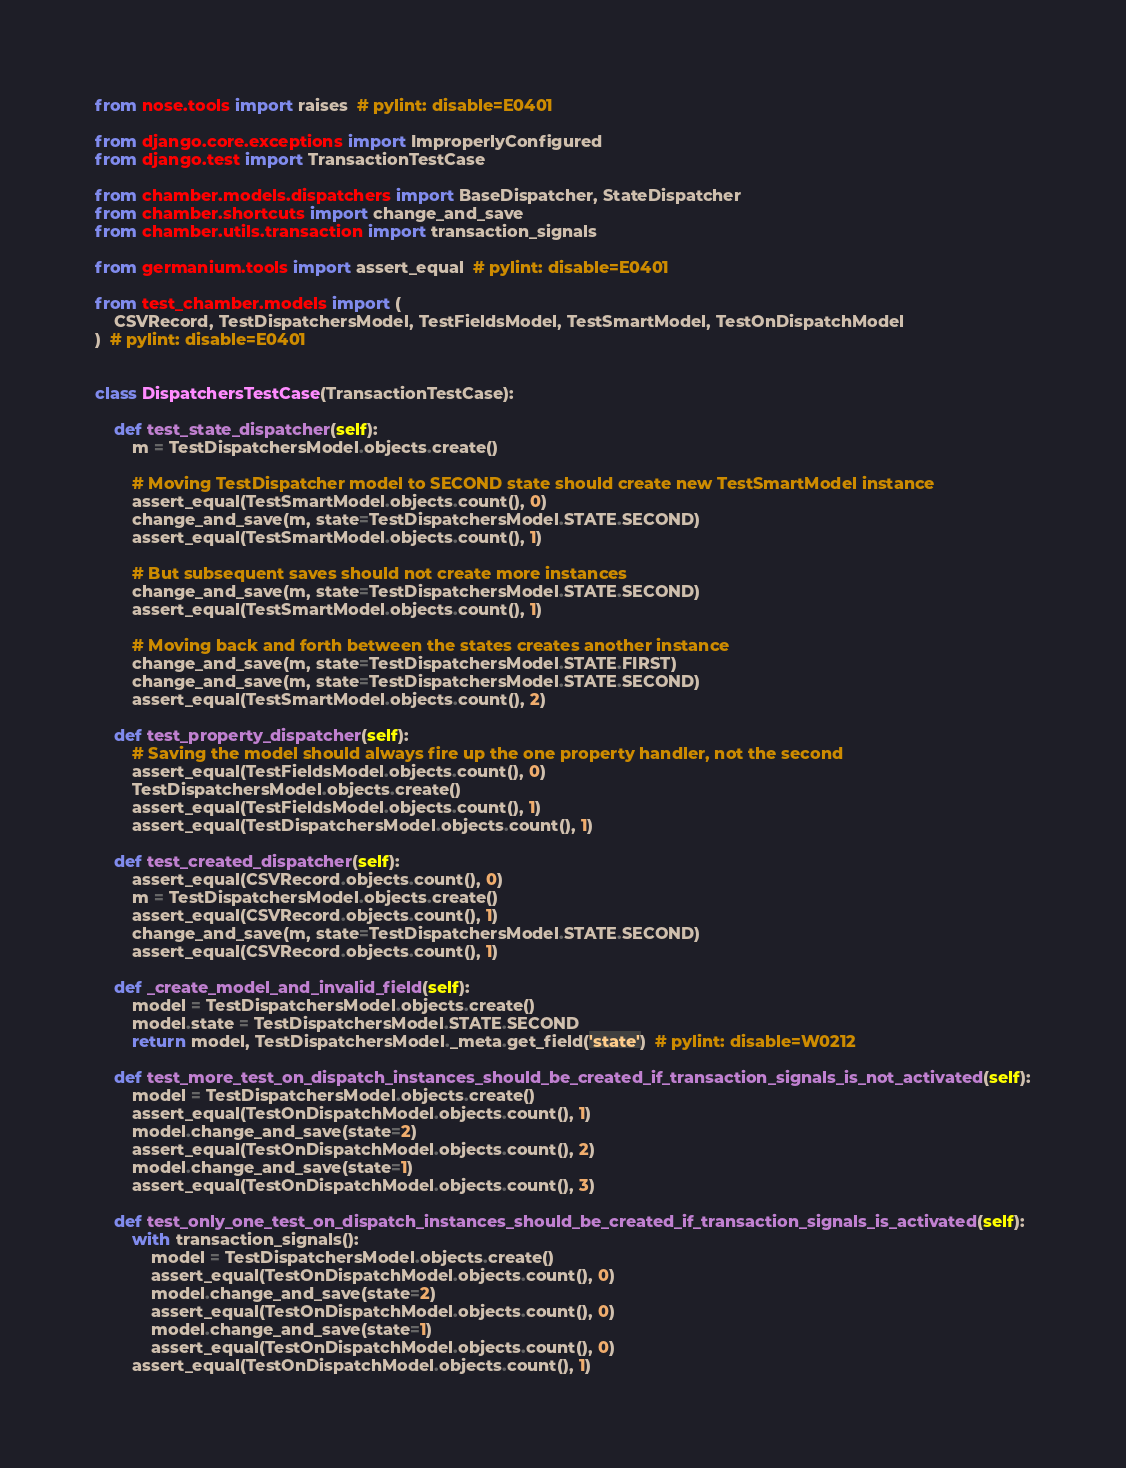Convert code to text. <code><loc_0><loc_0><loc_500><loc_500><_Python_>from nose.tools import raises  # pylint: disable=E0401

from django.core.exceptions import ImproperlyConfigured
from django.test import TransactionTestCase

from chamber.models.dispatchers import BaseDispatcher, StateDispatcher
from chamber.shortcuts import change_and_save
from chamber.utils.transaction import transaction_signals

from germanium.tools import assert_equal  # pylint: disable=E0401

from test_chamber.models import (
    CSVRecord, TestDispatchersModel, TestFieldsModel, TestSmartModel, TestOnDispatchModel
)  # pylint: disable=E0401


class DispatchersTestCase(TransactionTestCase):

    def test_state_dispatcher(self):
        m = TestDispatchersModel.objects.create()

        # Moving TestDispatcher model to SECOND state should create new TestSmartModel instance
        assert_equal(TestSmartModel.objects.count(), 0)
        change_and_save(m, state=TestDispatchersModel.STATE.SECOND)
        assert_equal(TestSmartModel.objects.count(), 1)

        # But subsequent saves should not create more instances
        change_and_save(m, state=TestDispatchersModel.STATE.SECOND)
        assert_equal(TestSmartModel.objects.count(), 1)

        # Moving back and forth between the states creates another instance
        change_and_save(m, state=TestDispatchersModel.STATE.FIRST)
        change_and_save(m, state=TestDispatchersModel.STATE.SECOND)
        assert_equal(TestSmartModel.objects.count(), 2)

    def test_property_dispatcher(self):
        # Saving the model should always fire up the one property handler, not the second
        assert_equal(TestFieldsModel.objects.count(), 0)
        TestDispatchersModel.objects.create()
        assert_equal(TestFieldsModel.objects.count(), 1)
        assert_equal(TestDispatchersModel.objects.count(), 1)

    def test_created_dispatcher(self):
        assert_equal(CSVRecord.objects.count(), 0)
        m = TestDispatchersModel.objects.create()
        assert_equal(CSVRecord.objects.count(), 1)
        change_and_save(m, state=TestDispatchersModel.STATE.SECOND)
        assert_equal(CSVRecord.objects.count(), 1)

    def _create_model_and_invalid_field(self):
        model = TestDispatchersModel.objects.create()
        model.state = TestDispatchersModel.STATE.SECOND
        return model, TestDispatchersModel._meta.get_field('state')  # pylint: disable=W0212

    def test_more_test_on_dispatch_instances_should_be_created_if_transaction_signals_is_not_activated(self):
        model = TestDispatchersModel.objects.create()
        assert_equal(TestOnDispatchModel.objects.count(), 1)
        model.change_and_save(state=2)
        assert_equal(TestOnDispatchModel.objects.count(), 2)
        model.change_and_save(state=1)
        assert_equal(TestOnDispatchModel.objects.count(), 3)

    def test_only_one_test_on_dispatch_instances_should_be_created_if_transaction_signals_is_activated(self):
        with transaction_signals():
            model = TestDispatchersModel.objects.create()
            assert_equal(TestOnDispatchModel.objects.count(), 0)
            model.change_and_save(state=2)
            assert_equal(TestOnDispatchModel.objects.count(), 0)
            model.change_and_save(state=1)
            assert_equal(TestOnDispatchModel.objects.count(), 0)
        assert_equal(TestOnDispatchModel.objects.count(), 1)
</code> 